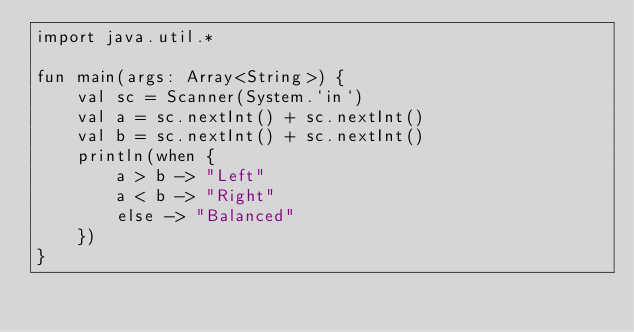<code> <loc_0><loc_0><loc_500><loc_500><_Kotlin_>import java.util.*

fun main(args: Array<String>) {
    val sc = Scanner(System.`in`)
    val a = sc.nextInt() + sc.nextInt()
    val b = sc.nextInt() + sc.nextInt()
    println(when {
        a > b -> "Left"
        a < b -> "Right"
        else -> "Balanced"
    })
}</code> 